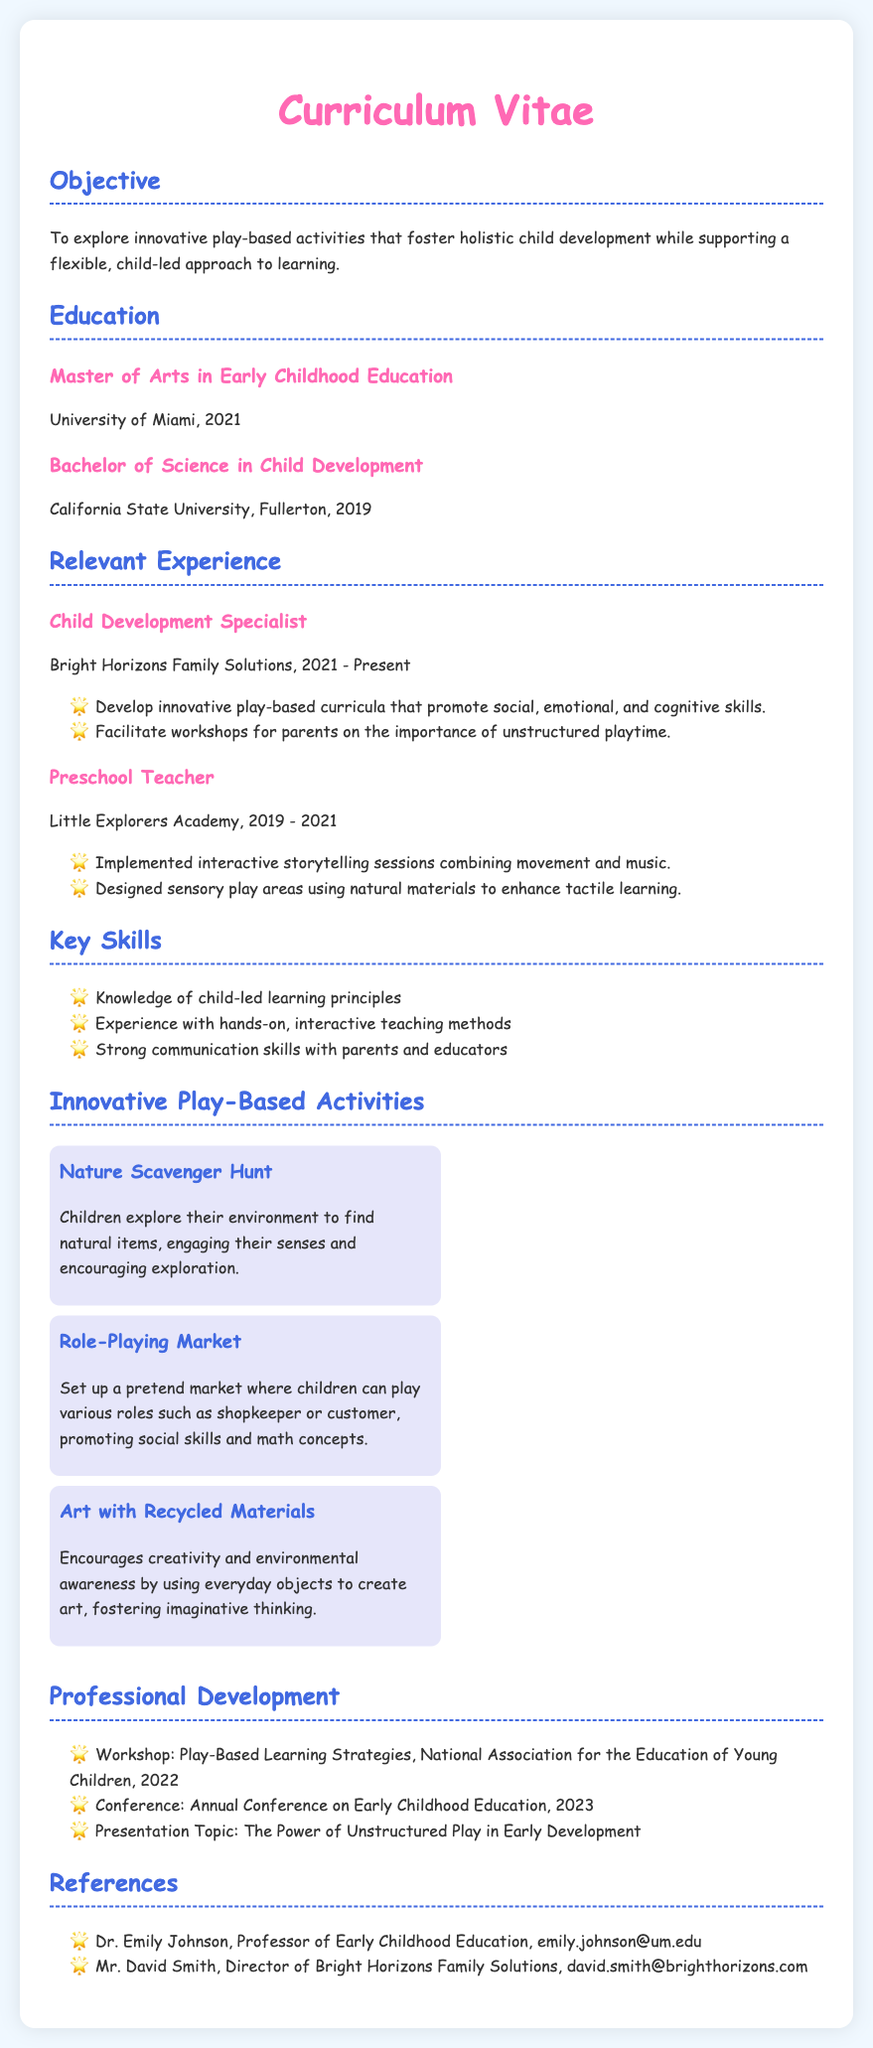What is the objective stated in the CV? The objective describes the aim of exploring play-based activities for child development while supporting a flexible learning approach.
Answer: To explore innovative play-based activities that foster holistic child development while supporting a flexible, child-led approach to learning What degree did the individual earn in 2021? The CV lists the Master's degree earned in that year.
Answer: Master of Arts in Early Childhood Education Where did the individual work as a Child Development Specialist? The CV specifies the name of the organization where the individual held this position.
Answer: Bright Horizons Family Solutions How many innovative play-based activities are listed in the CV? The section on innovative play-based activities contains multiple items, which can be counted.
Answer: 3 Which play-based activity encourages environmental awareness? The activity titles and descriptions provide insight into their focus.
Answer: Art with Recycled Materials What was the presentation topic mentioned in the Professional Development section? This topic highlights a focus within the individual's professional development activities.
Answer: The Power of Unstructured Play in Early Development Who is one of the references provided in the CV? The reference section lists professionals associated with the individual, which can be directly quoted.
Answer: Dr. Emily Johnson What type of learning principles is the individual knowledgeable about? The key skills section provides insight into the individual's expertise in educational approaches.
Answer: child-led learning principles 